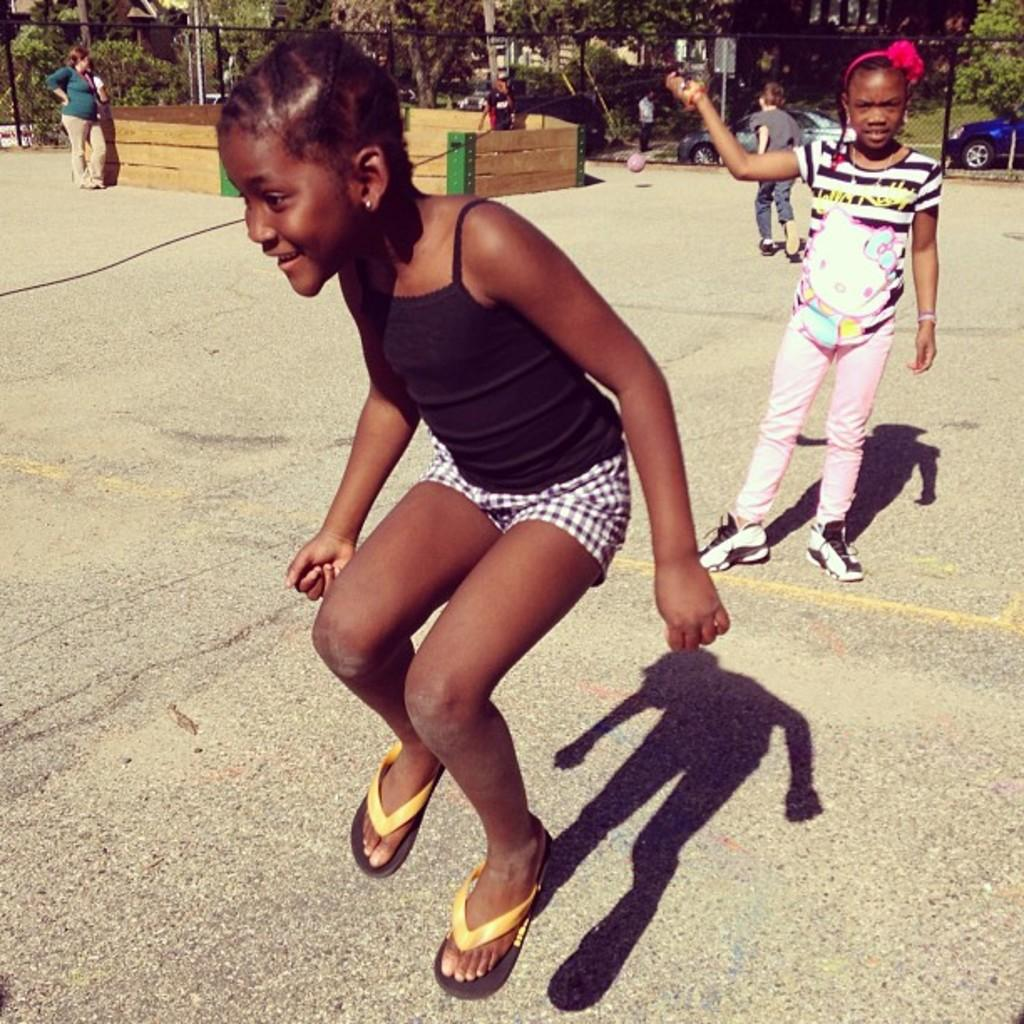Who or what can be seen in the image? There are people in the image. What is the purpose of the fence in the image? The fence serves as a barrier or boundary in the image. What type of natural elements are present in the image? There are trees in the image. What can be seen in the distance in the image? Cars are visible in the background of the image. What type of fact can be seen floating in the pail in the image? There is no pail or fact present in the image. 